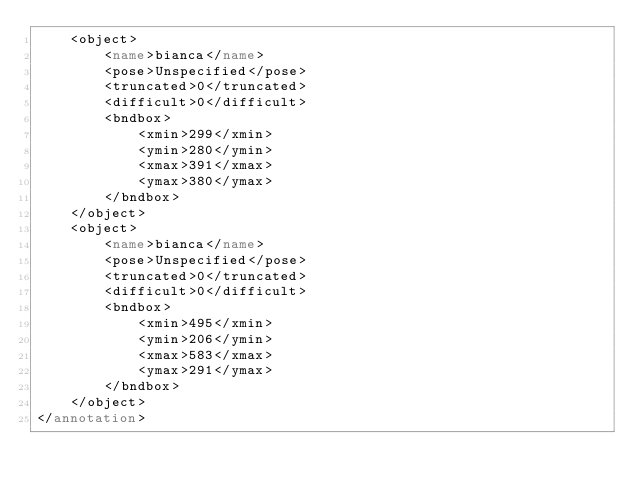Convert code to text. <code><loc_0><loc_0><loc_500><loc_500><_XML_>	<object>
		<name>bianca</name>
		<pose>Unspecified</pose>
		<truncated>0</truncated>
		<difficult>0</difficult>
		<bndbox>
			<xmin>299</xmin>
			<ymin>280</ymin>
			<xmax>391</xmax>
			<ymax>380</ymax>
		</bndbox>
	</object>
	<object>
		<name>bianca</name>
		<pose>Unspecified</pose>
		<truncated>0</truncated>
		<difficult>0</difficult>
		<bndbox>
			<xmin>495</xmin>
			<ymin>206</ymin>
			<xmax>583</xmax>
			<ymax>291</ymax>
		</bndbox>
	</object>
</annotation>
</code> 